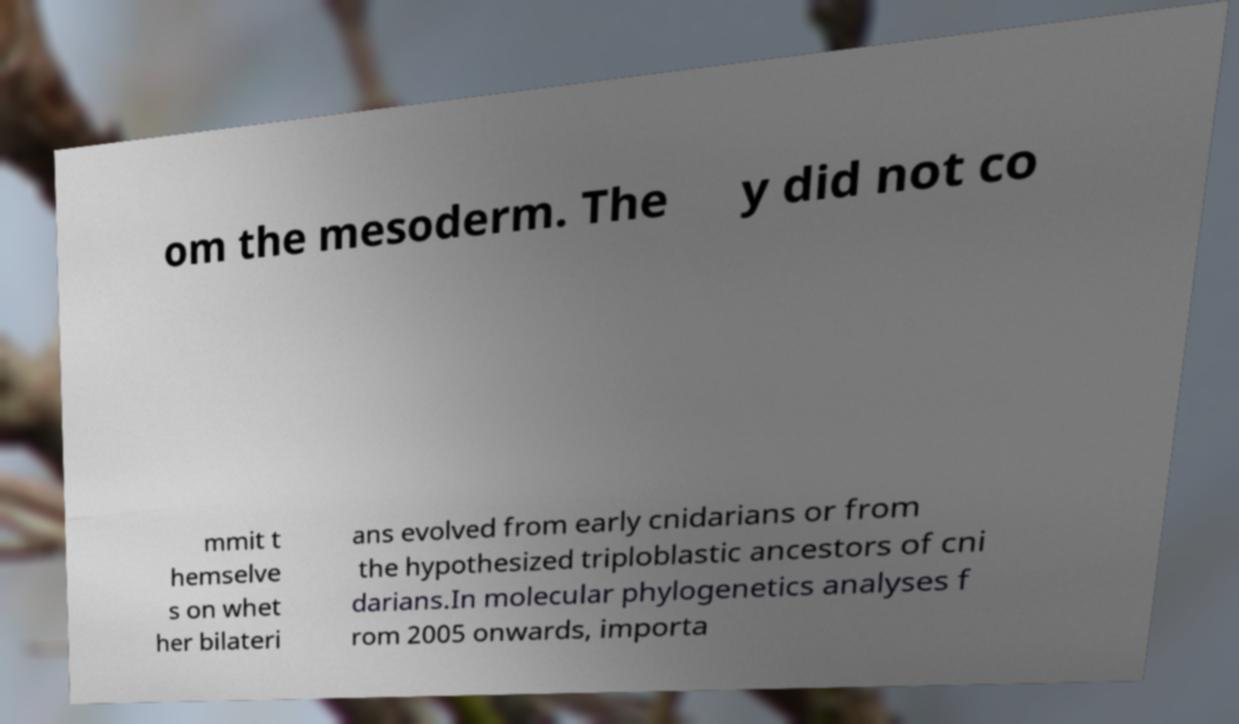Please identify and transcribe the text found in this image. om the mesoderm. The y did not co mmit t hemselve s on whet her bilateri ans evolved from early cnidarians or from the hypothesized triploblastic ancestors of cni darians.In molecular phylogenetics analyses f rom 2005 onwards, importa 